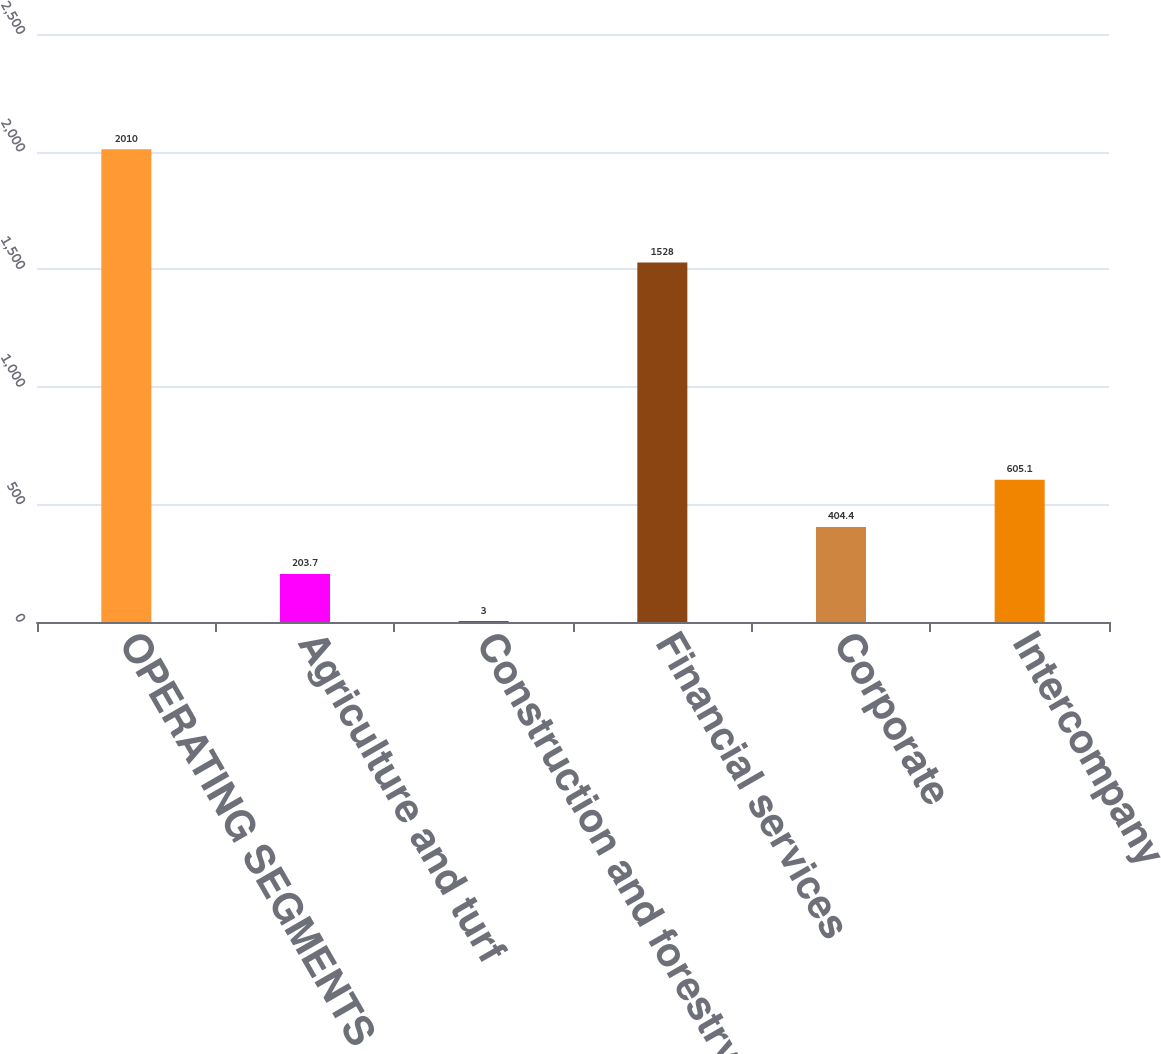<chart> <loc_0><loc_0><loc_500><loc_500><bar_chart><fcel>OPERATING SEGMENTS<fcel>Agriculture and turf<fcel>Construction and forestry<fcel>Financial services<fcel>Corporate<fcel>Intercompany<nl><fcel>2010<fcel>203.7<fcel>3<fcel>1528<fcel>404.4<fcel>605.1<nl></chart> 